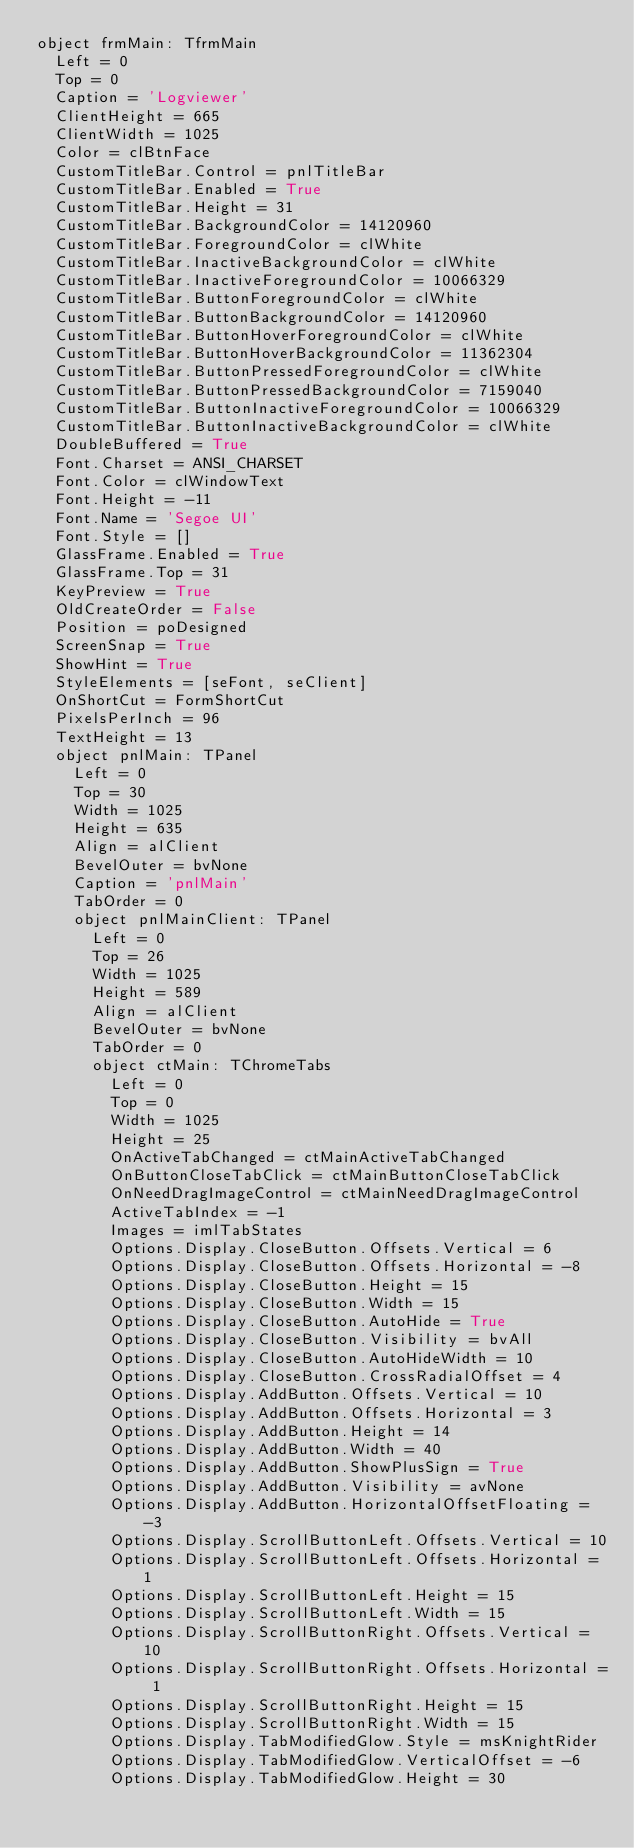<code> <loc_0><loc_0><loc_500><loc_500><_Pascal_>object frmMain: TfrmMain
  Left = 0
  Top = 0
  Caption = 'Logviewer'
  ClientHeight = 665
  ClientWidth = 1025
  Color = clBtnFace
  CustomTitleBar.Control = pnlTitleBar
  CustomTitleBar.Enabled = True
  CustomTitleBar.Height = 31
  CustomTitleBar.BackgroundColor = 14120960
  CustomTitleBar.ForegroundColor = clWhite
  CustomTitleBar.InactiveBackgroundColor = clWhite
  CustomTitleBar.InactiveForegroundColor = 10066329
  CustomTitleBar.ButtonForegroundColor = clWhite
  CustomTitleBar.ButtonBackgroundColor = 14120960
  CustomTitleBar.ButtonHoverForegroundColor = clWhite
  CustomTitleBar.ButtonHoverBackgroundColor = 11362304
  CustomTitleBar.ButtonPressedForegroundColor = clWhite
  CustomTitleBar.ButtonPressedBackgroundColor = 7159040
  CustomTitleBar.ButtonInactiveForegroundColor = 10066329
  CustomTitleBar.ButtonInactiveBackgroundColor = clWhite
  DoubleBuffered = True
  Font.Charset = ANSI_CHARSET
  Font.Color = clWindowText
  Font.Height = -11
  Font.Name = 'Segoe UI'
  Font.Style = []
  GlassFrame.Enabled = True
  GlassFrame.Top = 31
  KeyPreview = True
  OldCreateOrder = False
  Position = poDesigned
  ScreenSnap = True
  ShowHint = True
  StyleElements = [seFont, seClient]
  OnShortCut = FormShortCut
  PixelsPerInch = 96
  TextHeight = 13
  object pnlMain: TPanel
    Left = 0
    Top = 30
    Width = 1025
    Height = 635
    Align = alClient
    BevelOuter = bvNone
    Caption = 'pnlMain'
    TabOrder = 0
    object pnlMainClient: TPanel
      Left = 0
      Top = 26
      Width = 1025
      Height = 589
      Align = alClient
      BevelOuter = bvNone
      TabOrder = 0
      object ctMain: TChromeTabs
        Left = 0
        Top = 0
        Width = 1025
        Height = 25
        OnActiveTabChanged = ctMainActiveTabChanged
        OnButtonCloseTabClick = ctMainButtonCloseTabClick
        OnNeedDragImageControl = ctMainNeedDragImageControl
        ActiveTabIndex = -1
        Images = imlTabStates
        Options.Display.CloseButton.Offsets.Vertical = 6
        Options.Display.CloseButton.Offsets.Horizontal = -8
        Options.Display.CloseButton.Height = 15
        Options.Display.CloseButton.Width = 15
        Options.Display.CloseButton.AutoHide = True
        Options.Display.CloseButton.Visibility = bvAll
        Options.Display.CloseButton.AutoHideWidth = 10
        Options.Display.CloseButton.CrossRadialOffset = 4
        Options.Display.AddButton.Offsets.Vertical = 10
        Options.Display.AddButton.Offsets.Horizontal = 3
        Options.Display.AddButton.Height = 14
        Options.Display.AddButton.Width = 40
        Options.Display.AddButton.ShowPlusSign = True
        Options.Display.AddButton.Visibility = avNone
        Options.Display.AddButton.HorizontalOffsetFloating = -3
        Options.Display.ScrollButtonLeft.Offsets.Vertical = 10
        Options.Display.ScrollButtonLeft.Offsets.Horizontal = 1
        Options.Display.ScrollButtonLeft.Height = 15
        Options.Display.ScrollButtonLeft.Width = 15
        Options.Display.ScrollButtonRight.Offsets.Vertical = 10
        Options.Display.ScrollButtonRight.Offsets.Horizontal = 1
        Options.Display.ScrollButtonRight.Height = 15
        Options.Display.ScrollButtonRight.Width = 15
        Options.Display.TabModifiedGlow.Style = msKnightRider
        Options.Display.TabModifiedGlow.VerticalOffset = -6
        Options.Display.TabModifiedGlow.Height = 30</code> 